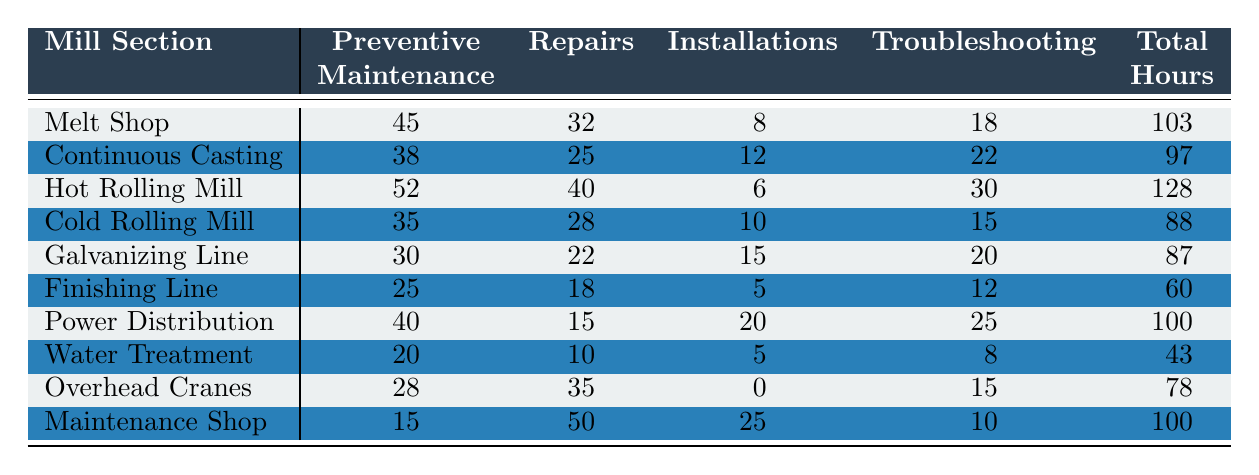What is the total number of hours electricians worked in the Hot Rolling Mill? From the table, the total hours for the Hot Rolling Mill is directly listed as 128 hours.
Answer: 128 Which mill section had the highest number of hours dedicated to Repairs? The Repairs column shows the highest value of 50 hours in the Maintenance Shop.
Answer: Maintenance Shop What is the total number of hours spent on Preventive Maintenance across all sections? Adding the values for Preventive Maintenance: 45 + 38 + 52 + 35 + 30 + 25 + 40 + 20 + 28 + 15 = 388 hours.
Answer: 388 Which mill section had the least total hours worked? Comparing the Total Hours column, the Water Treatment section has the least with 43 hours.
Answer: Water Treatment How many hours were spent on Installations in the Cold Rolling Mill? The Cold Rolling Mill has 10 hours recorded for Installations in the respective column.
Answer: 10 What is the average number of hours spent on Troubleshooting across all sections? Total hours for Troubleshooting: 18 + 22 + 30 + 15 + 20 + 12 + 25 + 8 + 15 + 10 =  180 hours across 10 sections results in an average of 180/10 = 18 hours.
Answer: 18 Did the Overhead Cranes section have more hours in Repairs than the Finishing Line? The Overhead Cranes had 35 hours in Repairs, while the Finishing Line had 18 hours, meaning Overhead Cranes had more.
Answer: Yes What is the total number of hours spent on Preventive Maintenance and Repairs combined in the Melt Shop? For the Melt Shop, Preventive Maintenance is 45 hours and Repairs is 32 hours, leading to a total of 45 + 32 = 77 hours.
Answer: 77 Which mill section had equal working hours for Preventive Maintenance and Total Hours? Checking the rows, no section had equal hours for Preventive Maintenance (which are all less than Total Hours).
Answer: None How many more hours were allocated to Repairs in the Maintenance Shop compared to the Power Distribution? The Maintenance Shop had 50 hours for Repairs while Power Distribution had 15 hours, which results in 50 - 15 = 35 hours more in Maintenance Shop.
Answer: 35 